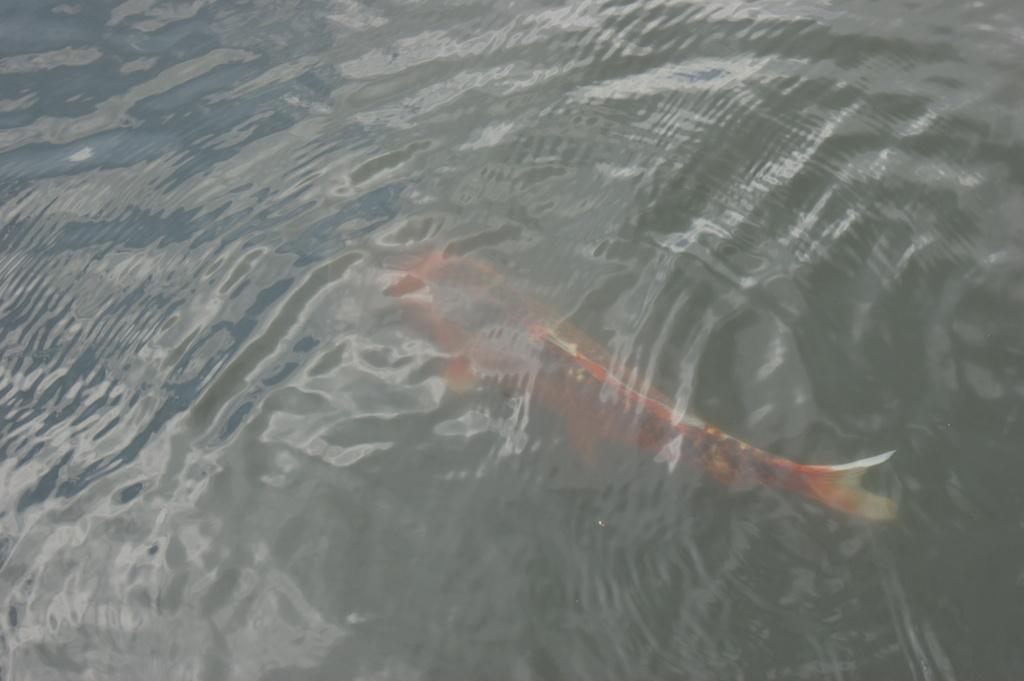In one or two sentences, can you explain what this image depicts? In the foreground of this image, there is a fish under the water. 